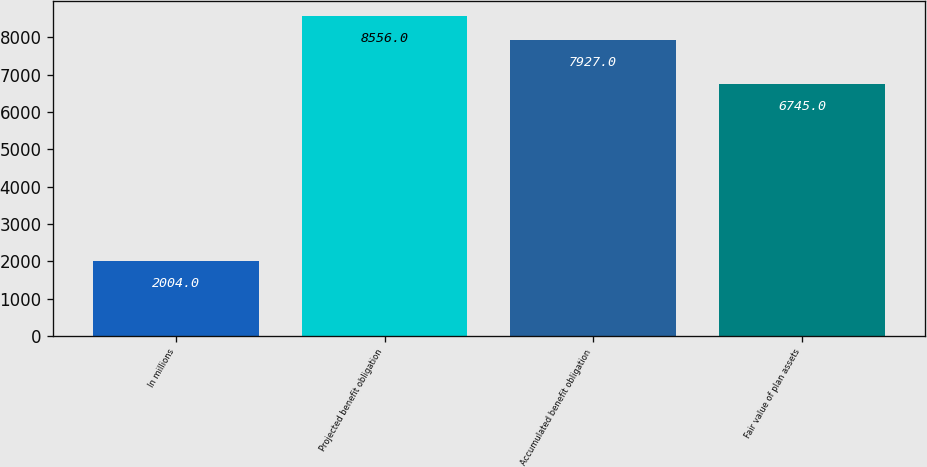Convert chart to OTSL. <chart><loc_0><loc_0><loc_500><loc_500><bar_chart><fcel>In millions<fcel>Projected benefit obligation<fcel>Accumulated benefit obligation<fcel>Fair value of plan assets<nl><fcel>2004<fcel>8556<fcel>7927<fcel>6745<nl></chart> 